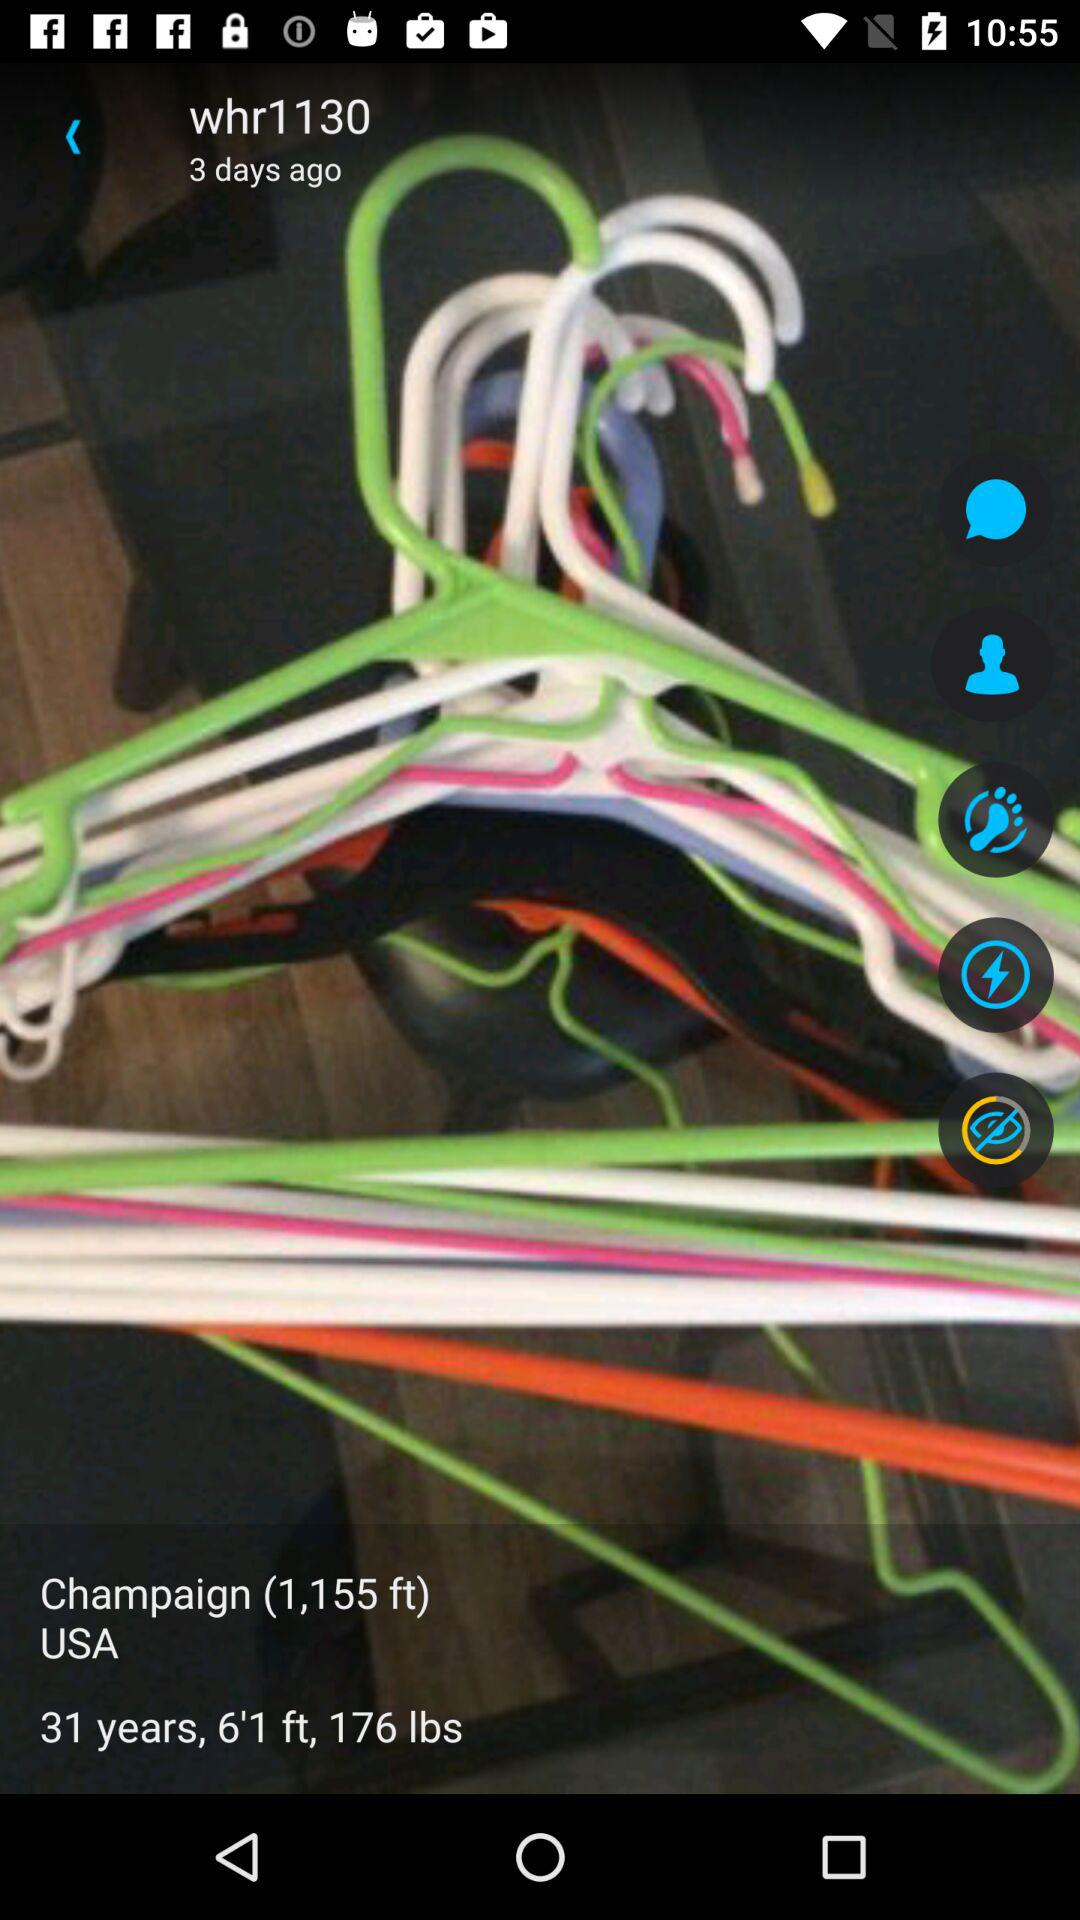How tall is the person? The person is 6 feet 1 inch tall. 